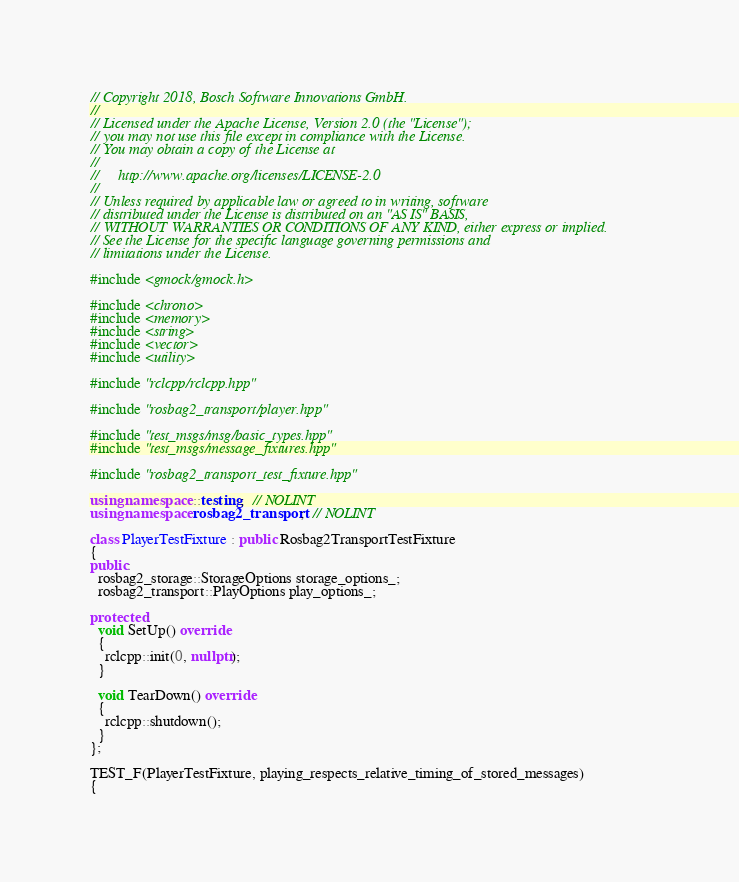<code> <loc_0><loc_0><loc_500><loc_500><_C++_>// Copyright 2018, Bosch Software Innovations GmbH.
//
// Licensed under the Apache License, Version 2.0 (the "License");
// you may not use this file except in compliance with the License.
// You may obtain a copy of the License at
//
//     http://www.apache.org/licenses/LICENSE-2.0
//
// Unless required by applicable law or agreed to in writing, software
// distributed under the License is distributed on an "AS IS" BASIS,
// WITHOUT WARRANTIES OR CONDITIONS OF ANY KIND, either express or implied.
// See the License for the specific language governing permissions and
// limitations under the License.

#include <gmock/gmock.h>

#include <chrono>
#include <memory>
#include <string>
#include <vector>
#include <utility>

#include "rclcpp/rclcpp.hpp"

#include "rosbag2_transport/player.hpp"

#include "test_msgs/msg/basic_types.hpp"
#include "test_msgs/message_fixtures.hpp"

#include "rosbag2_transport_test_fixture.hpp"

using namespace ::testing;  // NOLINT
using namespace rosbag2_transport;  // NOLINT

class PlayerTestFixture : public Rosbag2TransportTestFixture
{
public:
  rosbag2_storage::StorageOptions storage_options_;
  rosbag2_transport::PlayOptions play_options_;

protected:
  void SetUp() override
  {
    rclcpp::init(0, nullptr);
  }

  void TearDown() override
  {
    rclcpp::shutdown();
  }
};

TEST_F(PlayerTestFixture, playing_respects_relative_timing_of_stored_messages)
{</code> 